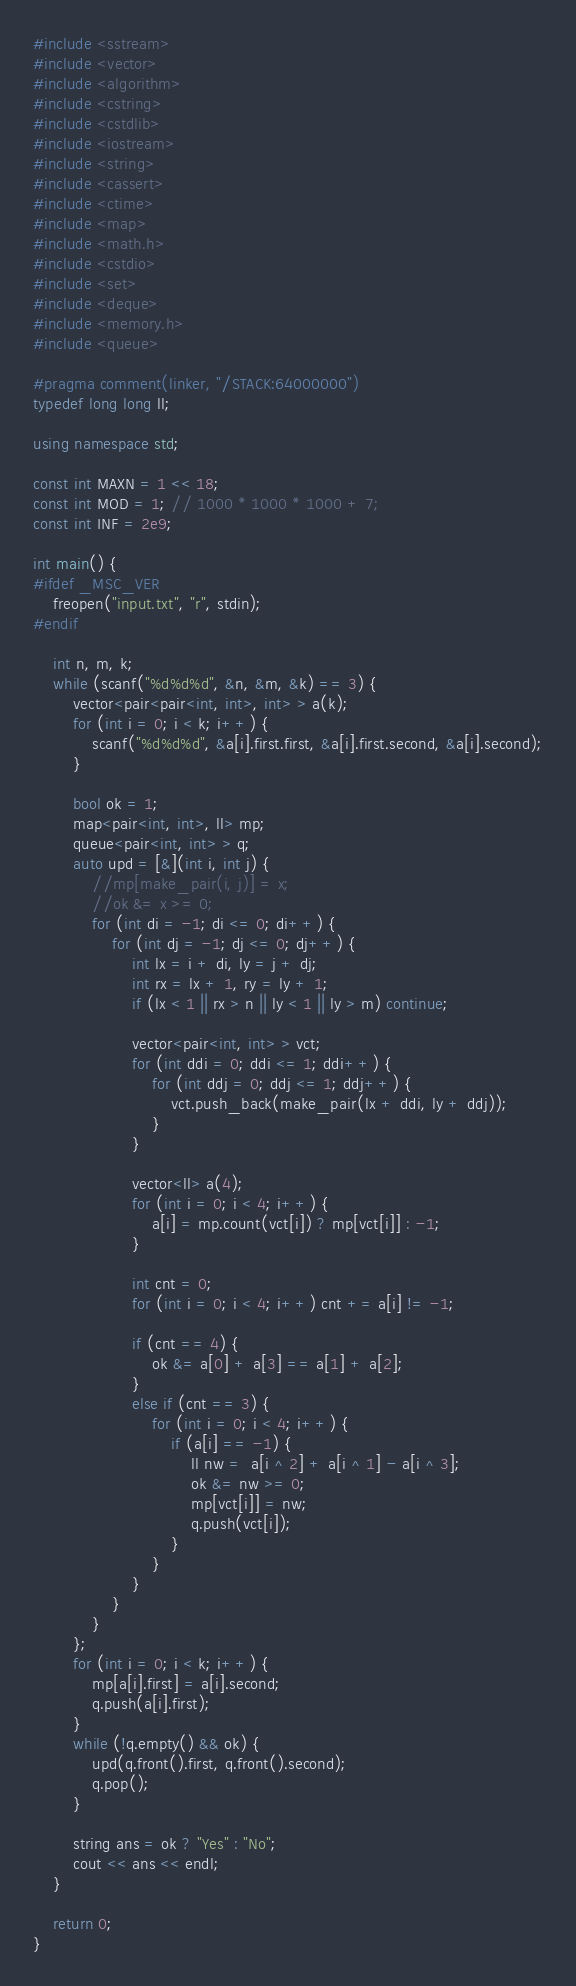<code> <loc_0><loc_0><loc_500><loc_500><_C++_>#include <sstream>
#include <vector>
#include <algorithm>
#include <cstring>
#include <cstdlib>
#include <iostream>
#include <string>
#include <cassert>
#include <ctime>
#include <map>
#include <math.h>
#include <cstdio>
#include <set>
#include <deque>
#include <memory.h>
#include <queue>

#pragma comment(linker, "/STACK:64000000")
typedef long long ll;

using namespace std;

const int MAXN = 1 << 18;
const int MOD = 1; // 1000 * 1000 * 1000 + 7;
const int INF = 2e9;

int main() {
#ifdef _MSC_VER
	freopen("input.txt", "r", stdin);
#endif

	int n, m, k;
	while (scanf("%d%d%d", &n, &m, &k) == 3) {
		vector<pair<pair<int, int>, int> > a(k);
		for (int i = 0; i < k; i++) {
			scanf("%d%d%d", &a[i].first.first, &a[i].first.second, &a[i].second);
		}

		bool ok = 1;
		map<pair<int, int>, ll> mp;
		queue<pair<int, int> > q;
		auto upd = [&](int i, int j) {
			//mp[make_pair(i, j)] = x;
			//ok &= x >= 0;
			for (int di = -1; di <= 0; di++) {
				for (int dj = -1; dj <= 0; dj++) {
					int lx = i + di, ly = j + dj;
					int rx = lx + 1, ry = ly + 1;
					if (lx < 1 || rx > n || ly < 1 || ly > m) continue;

					vector<pair<int, int> > vct;
					for (int ddi = 0; ddi <= 1; ddi++) {
						for (int ddj = 0; ddj <= 1; ddj++) {
							vct.push_back(make_pair(lx + ddi, ly + ddj));
						}
					}

					vector<ll> a(4);
					for (int i = 0; i < 4; i++) {
						a[i] = mp.count(vct[i]) ? mp[vct[i]] : -1;
					}

					int cnt = 0;
					for (int i = 0; i < 4; i++) cnt += a[i] != -1;

					if (cnt == 4) {
						ok &= a[0] + a[3] == a[1] + a[2];
					}
					else if (cnt == 3) {
						for (int i = 0; i < 4; i++) {
							if (a[i] == -1) {
								ll nw =  a[i ^ 2] + a[i ^ 1] - a[i ^ 3];
								ok &= nw >= 0;
								mp[vct[i]] = nw;
								q.push(vct[i]);
							}
						}
					}
				}
			}
		};
		for (int i = 0; i < k; i++) {
			mp[a[i].first] = a[i].second;
			q.push(a[i].first);
		}
		while (!q.empty() && ok) {
			upd(q.front().first, q.front().second);
			q.pop();
		}

		string ans = ok ? "Yes" : "No";
		cout << ans << endl;
	}

	return 0;
}</code> 